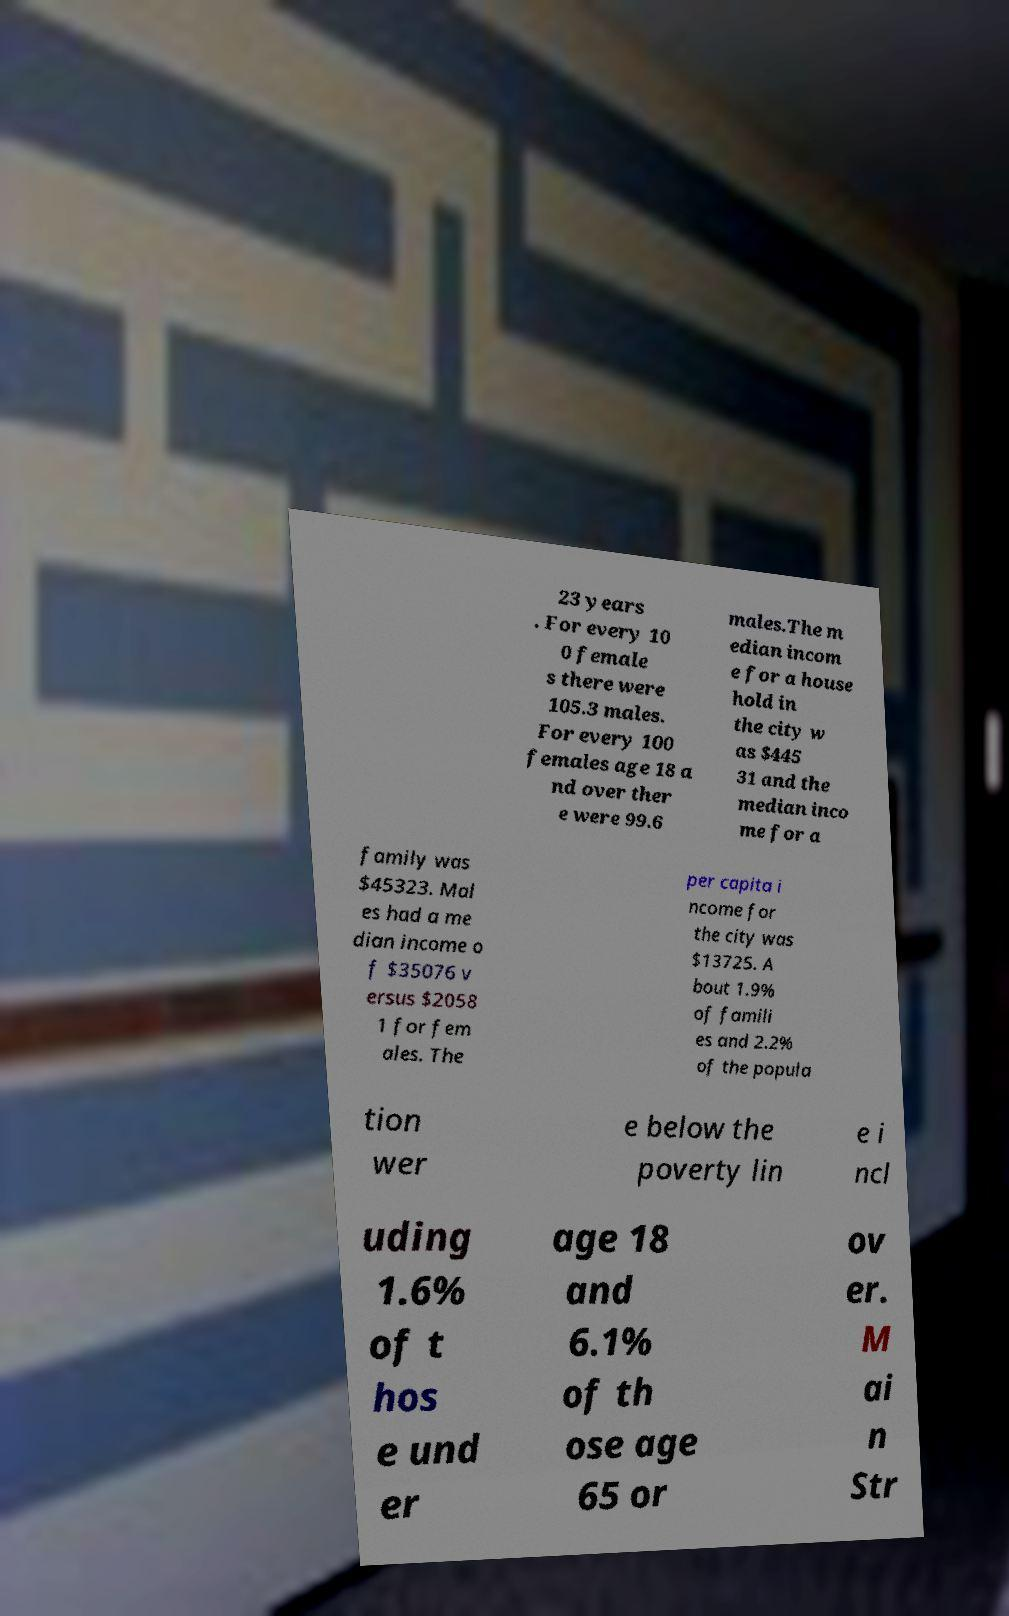Please identify and transcribe the text found in this image. 23 years . For every 10 0 female s there were 105.3 males. For every 100 females age 18 a nd over ther e were 99.6 males.The m edian incom e for a house hold in the city w as $445 31 and the median inco me for a family was $45323. Mal es had a me dian income o f $35076 v ersus $2058 1 for fem ales. The per capita i ncome for the city was $13725. A bout 1.9% of famili es and 2.2% of the popula tion wer e below the poverty lin e i ncl uding 1.6% of t hos e und er age 18 and 6.1% of th ose age 65 or ov er. M ai n Str 